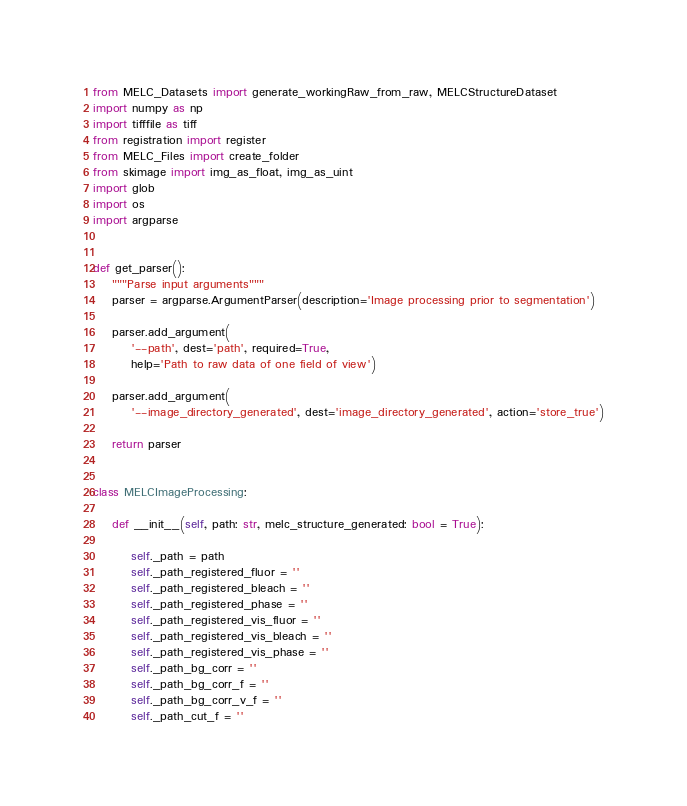Convert code to text. <code><loc_0><loc_0><loc_500><loc_500><_Python_>from MELC_Datasets import generate_workingRaw_from_raw, MELCStructureDataset
import numpy as np
import tifffile as tiff
from registration import register
from MELC_Files import create_folder
from skimage import img_as_float, img_as_uint
import glob
import os
import argparse


def get_parser():
    """Parse input arguments"""
    parser = argparse.ArgumentParser(description='Image processing prior to segmentation')

    parser.add_argument(
        '--path', dest='path', required=True,
        help='Path to raw data of one field of view')

    parser.add_argument(
        '--image_directory_generated', dest='image_directory_generated', action='store_true')

    return parser


class MELCImageProcessing:

    def __init__(self, path: str, melc_structure_generated: bool = True):

        self._path = path
        self._path_registered_fluor = ''
        self._path_registered_bleach = ''
        self._path_registered_phase = ''
        self._path_registered_vis_fluor = ''
        self._path_registered_vis_bleach = ''
        self._path_registered_vis_phase = ''
        self._path_bg_corr = ''
        self._path_bg_corr_f = ''
        self._path_bg_corr_v_f = ''
        self._path_cut_f = ''</code> 